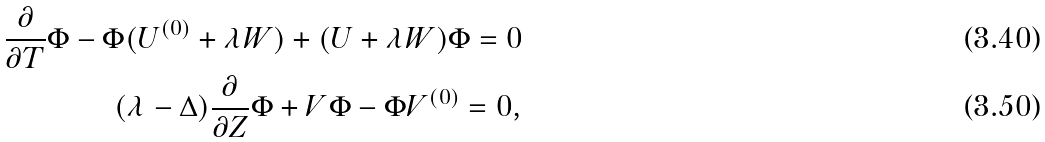Convert formula to latex. <formula><loc_0><loc_0><loc_500><loc_500>\frac { \partial } { \partial T } \Phi - \Phi ( U ^ { ( 0 ) } + \lambda W ) + ( U + \lambda W ) \Phi = 0 \\ ( \lambda - \Delta ) \frac { \partial } { \partial Z } \Phi + V \Phi - \Phi V ^ { ( 0 ) } = 0 ,</formula> 